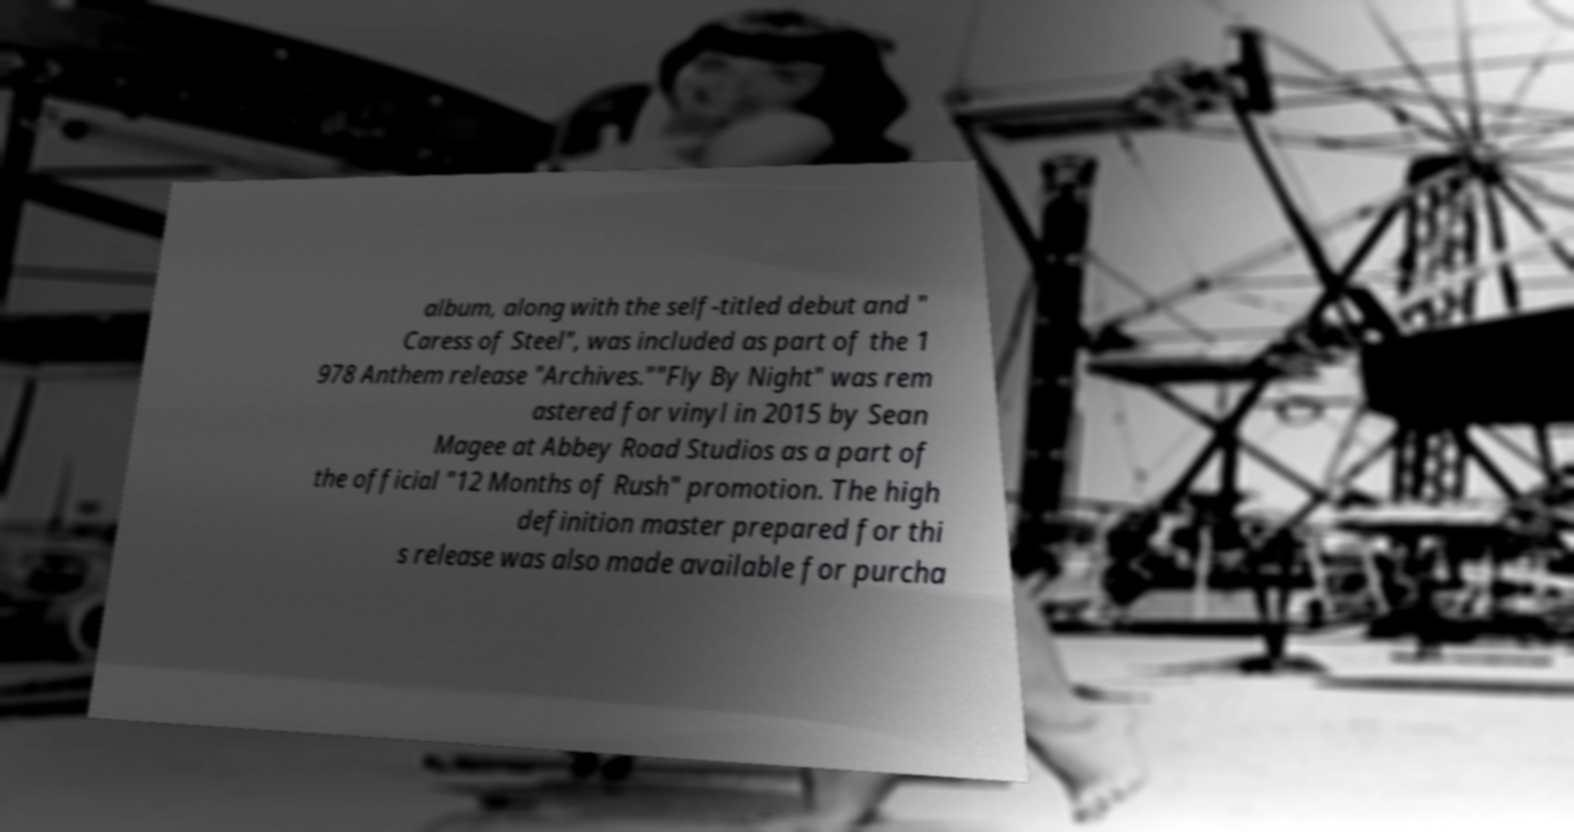Please identify and transcribe the text found in this image. album, along with the self-titled debut and " Caress of Steel", was included as part of the 1 978 Anthem release "Archives.""Fly By Night" was rem astered for vinyl in 2015 by Sean Magee at Abbey Road Studios as a part of the official "12 Months of Rush" promotion. The high definition master prepared for thi s release was also made available for purcha 